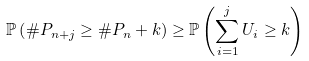<formula> <loc_0><loc_0><loc_500><loc_500>\mathbb { P } \left ( \# P _ { n + j } \geq \# P _ { n } + k \right ) \geq \mathbb { P } \left ( \sum _ { i = 1 } ^ { j } U _ { i } \geq k \right )</formula> 